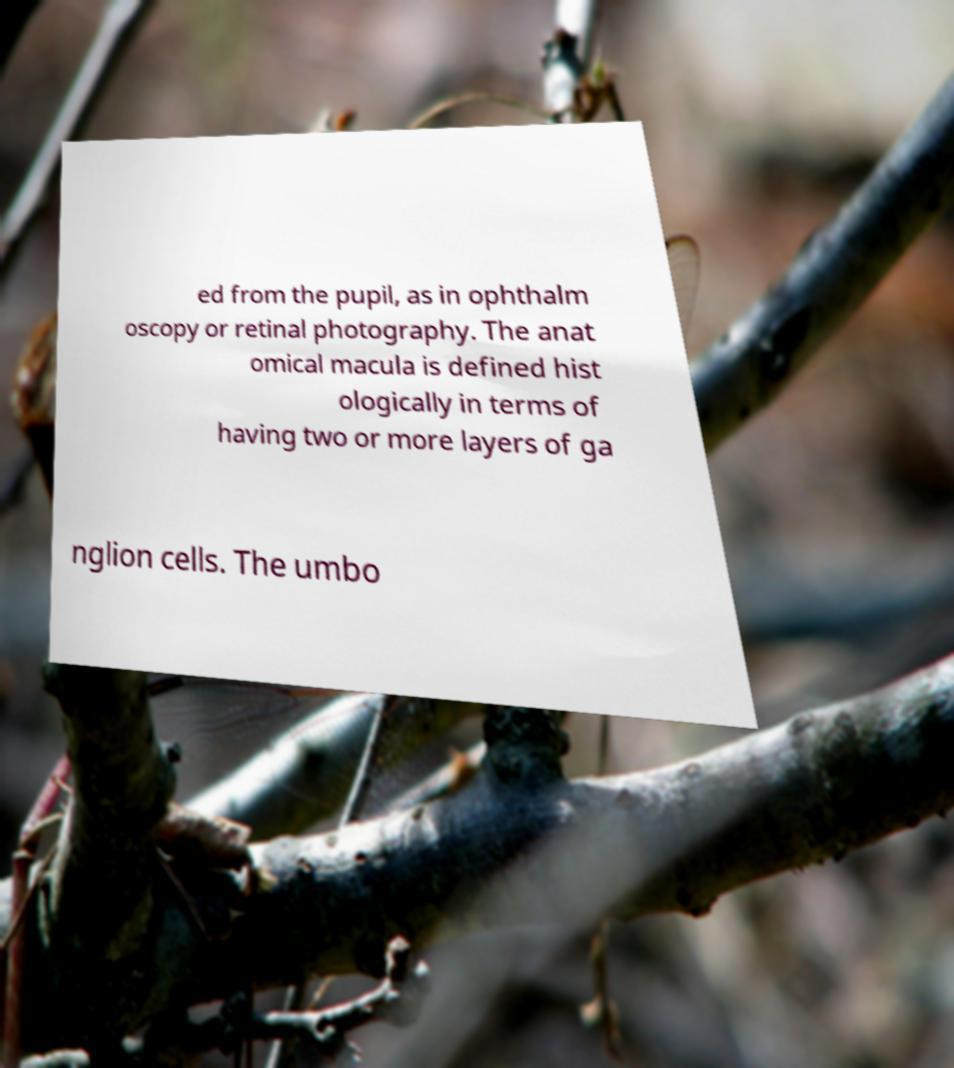There's text embedded in this image that I need extracted. Can you transcribe it verbatim? ed from the pupil, as in ophthalm oscopy or retinal photography. The anat omical macula is defined hist ologically in terms of having two or more layers of ga nglion cells. The umbo 